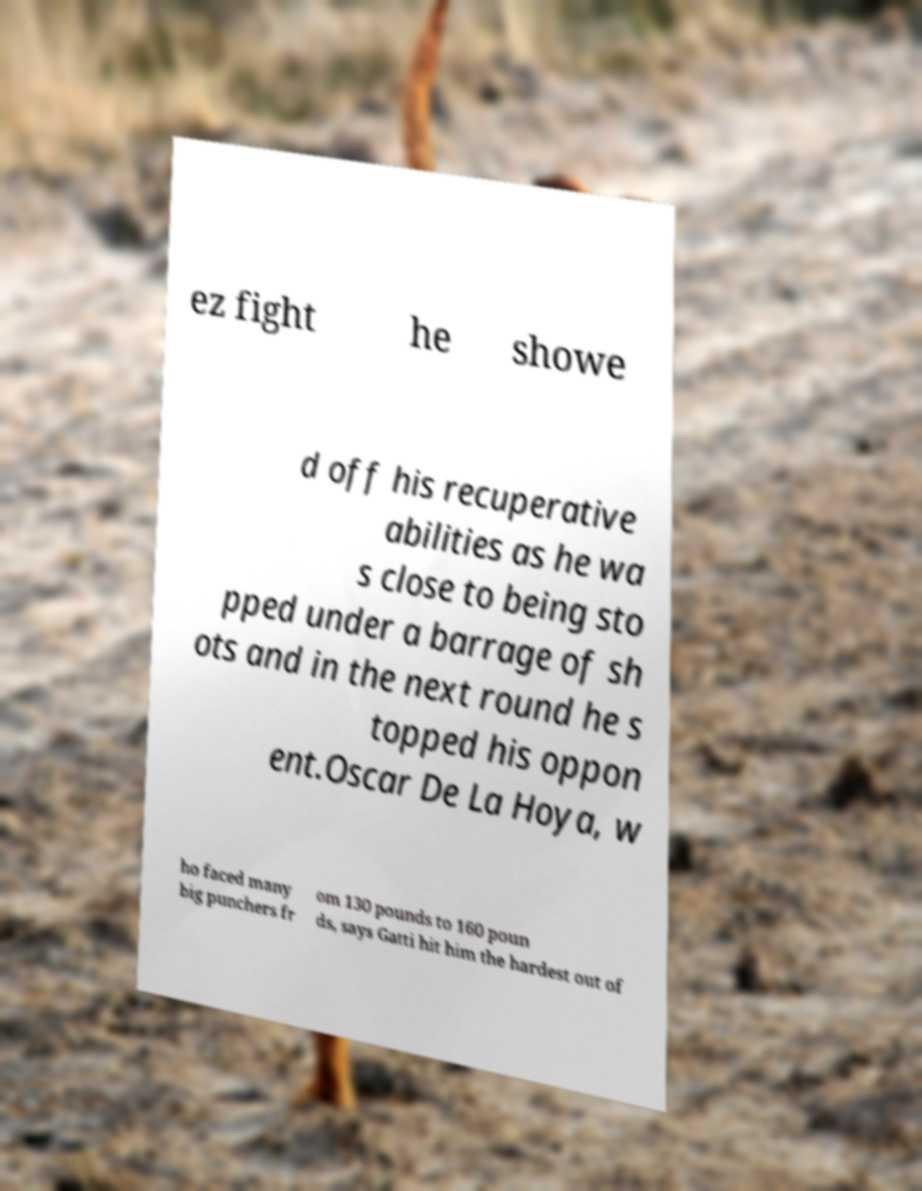Please read and relay the text visible in this image. What does it say? ez fight he showe d off his recuperative abilities as he wa s close to being sto pped under a barrage of sh ots and in the next round he s topped his oppon ent.Oscar De La Hoya, w ho faced many big punchers fr om 130 pounds to 160 poun ds, says Gatti hit him the hardest out of 